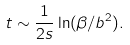Convert formula to latex. <formula><loc_0><loc_0><loc_500><loc_500>t \sim \frac { 1 } { 2 s } \ln ( \beta / b ^ { 2 } ) .</formula> 